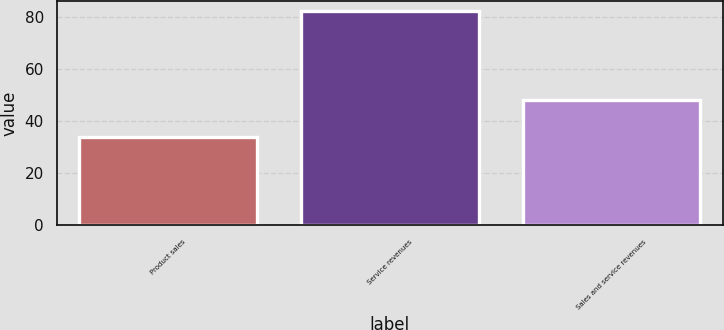<chart> <loc_0><loc_0><loc_500><loc_500><bar_chart><fcel>Product sales<fcel>Service revenues<fcel>Sales and service revenues<nl><fcel>34<fcel>82<fcel>48<nl></chart> 